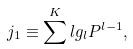<formula> <loc_0><loc_0><loc_500><loc_500>j _ { 1 } \equiv \sum ^ { K } l g _ { l } P ^ { l - 1 } ,</formula> 